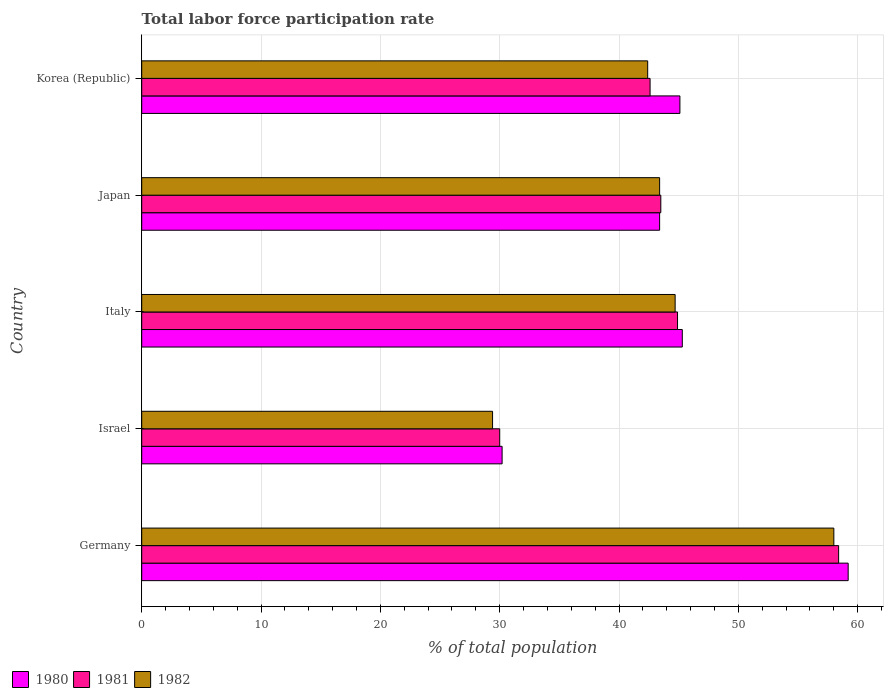How many groups of bars are there?
Offer a terse response. 5. Are the number of bars per tick equal to the number of legend labels?
Your answer should be compact. Yes. Are the number of bars on each tick of the Y-axis equal?
Ensure brevity in your answer.  Yes. What is the total labor force participation rate in 1982 in Israel?
Your answer should be very brief. 29.4. Across all countries, what is the maximum total labor force participation rate in 1980?
Offer a terse response. 59.2. Across all countries, what is the minimum total labor force participation rate in 1980?
Provide a short and direct response. 30.2. In which country was the total labor force participation rate in 1982 maximum?
Ensure brevity in your answer.  Germany. In which country was the total labor force participation rate in 1980 minimum?
Your response must be concise. Israel. What is the total total labor force participation rate in 1981 in the graph?
Make the answer very short. 219.4. What is the difference between the total labor force participation rate in 1981 in Italy and that in Korea (Republic)?
Offer a very short reply. 2.3. What is the difference between the total labor force participation rate in 1982 in Japan and the total labor force participation rate in 1981 in Korea (Republic)?
Offer a terse response. 0.8. What is the average total labor force participation rate in 1980 per country?
Your answer should be very brief. 44.64. What is the difference between the total labor force participation rate in 1982 and total labor force participation rate in 1980 in Italy?
Offer a terse response. -0.6. In how many countries, is the total labor force participation rate in 1982 greater than 16 %?
Offer a very short reply. 5. What is the ratio of the total labor force participation rate in 1980 in Italy to that in Japan?
Make the answer very short. 1.04. Is the total labor force participation rate in 1982 in Israel less than that in Italy?
Your response must be concise. Yes. What is the difference between the highest and the second highest total labor force participation rate in 1980?
Your answer should be very brief. 13.9. What is the difference between the highest and the lowest total labor force participation rate in 1980?
Your answer should be very brief. 29. In how many countries, is the total labor force participation rate in 1981 greater than the average total labor force participation rate in 1981 taken over all countries?
Provide a short and direct response. 2. What does the 1st bar from the top in Germany represents?
Keep it short and to the point. 1982. Is it the case that in every country, the sum of the total labor force participation rate in 1980 and total labor force participation rate in 1982 is greater than the total labor force participation rate in 1981?
Offer a terse response. Yes. How many countries are there in the graph?
Your answer should be very brief. 5. Are the values on the major ticks of X-axis written in scientific E-notation?
Make the answer very short. No. Where does the legend appear in the graph?
Your answer should be compact. Bottom left. How many legend labels are there?
Offer a terse response. 3. How are the legend labels stacked?
Your answer should be very brief. Horizontal. What is the title of the graph?
Your answer should be very brief. Total labor force participation rate. Does "1975" appear as one of the legend labels in the graph?
Give a very brief answer. No. What is the label or title of the X-axis?
Provide a short and direct response. % of total population. What is the label or title of the Y-axis?
Provide a succinct answer. Country. What is the % of total population of 1980 in Germany?
Provide a short and direct response. 59.2. What is the % of total population in 1981 in Germany?
Ensure brevity in your answer.  58.4. What is the % of total population of 1980 in Israel?
Offer a terse response. 30.2. What is the % of total population of 1981 in Israel?
Keep it short and to the point. 30. What is the % of total population in 1982 in Israel?
Offer a terse response. 29.4. What is the % of total population of 1980 in Italy?
Keep it short and to the point. 45.3. What is the % of total population of 1981 in Italy?
Your answer should be very brief. 44.9. What is the % of total population of 1982 in Italy?
Your answer should be very brief. 44.7. What is the % of total population in 1980 in Japan?
Your answer should be very brief. 43.4. What is the % of total population in 1981 in Japan?
Provide a short and direct response. 43.5. What is the % of total population of 1982 in Japan?
Offer a very short reply. 43.4. What is the % of total population of 1980 in Korea (Republic)?
Your response must be concise. 45.1. What is the % of total population in 1981 in Korea (Republic)?
Provide a succinct answer. 42.6. What is the % of total population in 1982 in Korea (Republic)?
Make the answer very short. 42.4. Across all countries, what is the maximum % of total population of 1980?
Your response must be concise. 59.2. Across all countries, what is the maximum % of total population of 1981?
Offer a very short reply. 58.4. Across all countries, what is the maximum % of total population of 1982?
Your answer should be very brief. 58. Across all countries, what is the minimum % of total population in 1980?
Your answer should be very brief. 30.2. Across all countries, what is the minimum % of total population of 1982?
Offer a terse response. 29.4. What is the total % of total population of 1980 in the graph?
Give a very brief answer. 223.2. What is the total % of total population of 1981 in the graph?
Ensure brevity in your answer.  219.4. What is the total % of total population of 1982 in the graph?
Your response must be concise. 217.9. What is the difference between the % of total population of 1981 in Germany and that in Israel?
Make the answer very short. 28.4. What is the difference between the % of total population in 1982 in Germany and that in Israel?
Offer a terse response. 28.6. What is the difference between the % of total population in 1981 in Germany and that in Italy?
Offer a very short reply. 13.5. What is the difference between the % of total population of 1980 in Israel and that in Italy?
Your answer should be very brief. -15.1. What is the difference between the % of total population of 1981 in Israel and that in Italy?
Your response must be concise. -14.9. What is the difference between the % of total population in 1982 in Israel and that in Italy?
Provide a succinct answer. -15.3. What is the difference between the % of total population of 1981 in Israel and that in Japan?
Your answer should be very brief. -13.5. What is the difference between the % of total population in 1982 in Israel and that in Japan?
Your response must be concise. -14. What is the difference between the % of total population in 1980 in Israel and that in Korea (Republic)?
Give a very brief answer. -14.9. What is the difference between the % of total population in 1981 in Israel and that in Korea (Republic)?
Offer a terse response. -12.6. What is the difference between the % of total population of 1982 in Israel and that in Korea (Republic)?
Your response must be concise. -13. What is the difference between the % of total population of 1980 in Italy and that in Japan?
Ensure brevity in your answer.  1.9. What is the difference between the % of total population of 1982 in Italy and that in Korea (Republic)?
Provide a succinct answer. 2.3. What is the difference between the % of total population of 1980 in Japan and that in Korea (Republic)?
Your response must be concise. -1.7. What is the difference between the % of total population of 1981 in Japan and that in Korea (Republic)?
Your response must be concise. 0.9. What is the difference between the % of total population of 1980 in Germany and the % of total population of 1981 in Israel?
Provide a succinct answer. 29.2. What is the difference between the % of total population of 1980 in Germany and the % of total population of 1982 in Israel?
Give a very brief answer. 29.8. What is the difference between the % of total population of 1980 in Germany and the % of total population of 1982 in Italy?
Provide a short and direct response. 14.5. What is the difference between the % of total population in 1980 in Germany and the % of total population in 1981 in Japan?
Make the answer very short. 15.7. What is the difference between the % of total population in 1980 in Germany and the % of total population in 1981 in Korea (Republic)?
Give a very brief answer. 16.6. What is the difference between the % of total population in 1980 in Israel and the % of total population in 1981 in Italy?
Offer a very short reply. -14.7. What is the difference between the % of total population in 1980 in Israel and the % of total population in 1982 in Italy?
Offer a very short reply. -14.5. What is the difference between the % of total population in 1981 in Israel and the % of total population in 1982 in Italy?
Your response must be concise. -14.7. What is the difference between the % of total population in 1980 in Israel and the % of total population in 1981 in Japan?
Your answer should be very brief. -13.3. What is the difference between the % of total population of 1980 in Israel and the % of total population of 1981 in Korea (Republic)?
Offer a terse response. -12.4. What is the difference between the % of total population in 1980 in Israel and the % of total population in 1982 in Korea (Republic)?
Give a very brief answer. -12.2. What is the difference between the % of total population in 1980 in Italy and the % of total population in 1982 in Japan?
Keep it short and to the point. 1.9. What is the difference between the % of total population in 1981 in Italy and the % of total population in 1982 in Japan?
Give a very brief answer. 1.5. What is the difference between the % of total population in 1980 in Italy and the % of total population in 1982 in Korea (Republic)?
Provide a short and direct response. 2.9. What is the average % of total population in 1980 per country?
Offer a terse response. 44.64. What is the average % of total population in 1981 per country?
Offer a very short reply. 43.88. What is the average % of total population in 1982 per country?
Provide a succinct answer. 43.58. What is the difference between the % of total population of 1980 and % of total population of 1982 in Germany?
Provide a short and direct response. 1.2. What is the difference between the % of total population in 1981 and % of total population in 1982 in Germany?
Your answer should be compact. 0.4. What is the difference between the % of total population in 1980 and % of total population in 1981 in Israel?
Your response must be concise. 0.2. What is the difference between the % of total population of 1981 and % of total population of 1982 in Israel?
Your answer should be very brief. 0.6. What is the difference between the % of total population in 1980 and % of total population in 1981 in Italy?
Make the answer very short. 0.4. What is the difference between the % of total population in 1980 and % of total population in 1982 in Japan?
Your response must be concise. 0. What is the difference between the % of total population of 1980 and % of total population of 1982 in Korea (Republic)?
Your answer should be compact. 2.7. What is the ratio of the % of total population of 1980 in Germany to that in Israel?
Offer a very short reply. 1.96. What is the ratio of the % of total population in 1981 in Germany to that in Israel?
Provide a succinct answer. 1.95. What is the ratio of the % of total population in 1982 in Germany to that in Israel?
Your response must be concise. 1.97. What is the ratio of the % of total population of 1980 in Germany to that in Italy?
Offer a terse response. 1.31. What is the ratio of the % of total population of 1981 in Germany to that in Italy?
Ensure brevity in your answer.  1.3. What is the ratio of the % of total population of 1982 in Germany to that in Italy?
Offer a terse response. 1.3. What is the ratio of the % of total population of 1980 in Germany to that in Japan?
Provide a succinct answer. 1.36. What is the ratio of the % of total population of 1981 in Germany to that in Japan?
Provide a short and direct response. 1.34. What is the ratio of the % of total population of 1982 in Germany to that in Japan?
Provide a succinct answer. 1.34. What is the ratio of the % of total population of 1980 in Germany to that in Korea (Republic)?
Your answer should be very brief. 1.31. What is the ratio of the % of total population of 1981 in Germany to that in Korea (Republic)?
Provide a succinct answer. 1.37. What is the ratio of the % of total population in 1982 in Germany to that in Korea (Republic)?
Keep it short and to the point. 1.37. What is the ratio of the % of total population of 1981 in Israel to that in Italy?
Your answer should be compact. 0.67. What is the ratio of the % of total population of 1982 in Israel to that in Italy?
Your answer should be very brief. 0.66. What is the ratio of the % of total population in 1980 in Israel to that in Japan?
Your answer should be compact. 0.7. What is the ratio of the % of total population in 1981 in Israel to that in Japan?
Keep it short and to the point. 0.69. What is the ratio of the % of total population of 1982 in Israel to that in Japan?
Make the answer very short. 0.68. What is the ratio of the % of total population in 1980 in Israel to that in Korea (Republic)?
Keep it short and to the point. 0.67. What is the ratio of the % of total population in 1981 in Israel to that in Korea (Republic)?
Keep it short and to the point. 0.7. What is the ratio of the % of total population in 1982 in Israel to that in Korea (Republic)?
Provide a succinct answer. 0.69. What is the ratio of the % of total population of 1980 in Italy to that in Japan?
Your answer should be very brief. 1.04. What is the ratio of the % of total population in 1981 in Italy to that in Japan?
Your answer should be very brief. 1.03. What is the ratio of the % of total population in 1981 in Italy to that in Korea (Republic)?
Keep it short and to the point. 1.05. What is the ratio of the % of total population of 1982 in Italy to that in Korea (Republic)?
Offer a very short reply. 1.05. What is the ratio of the % of total population in 1980 in Japan to that in Korea (Republic)?
Provide a short and direct response. 0.96. What is the ratio of the % of total population in 1981 in Japan to that in Korea (Republic)?
Offer a very short reply. 1.02. What is the ratio of the % of total population of 1982 in Japan to that in Korea (Republic)?
Your response must be concise. 1.02. What is the difference between the highest and the second highest % of total population in 1981?
Your answer should be very brief. 13.5. What is the difference between the highest and the second highest % of total population of 1982?
Offer a terse response. 13.3. What is the difference between the highest and the lowest % of total population in 1981?
Give a very brief answer. 28.4. What is the difference between the highest and the lowest % of total population of 1982?
Ensure brevity in your answer.  28.6. 